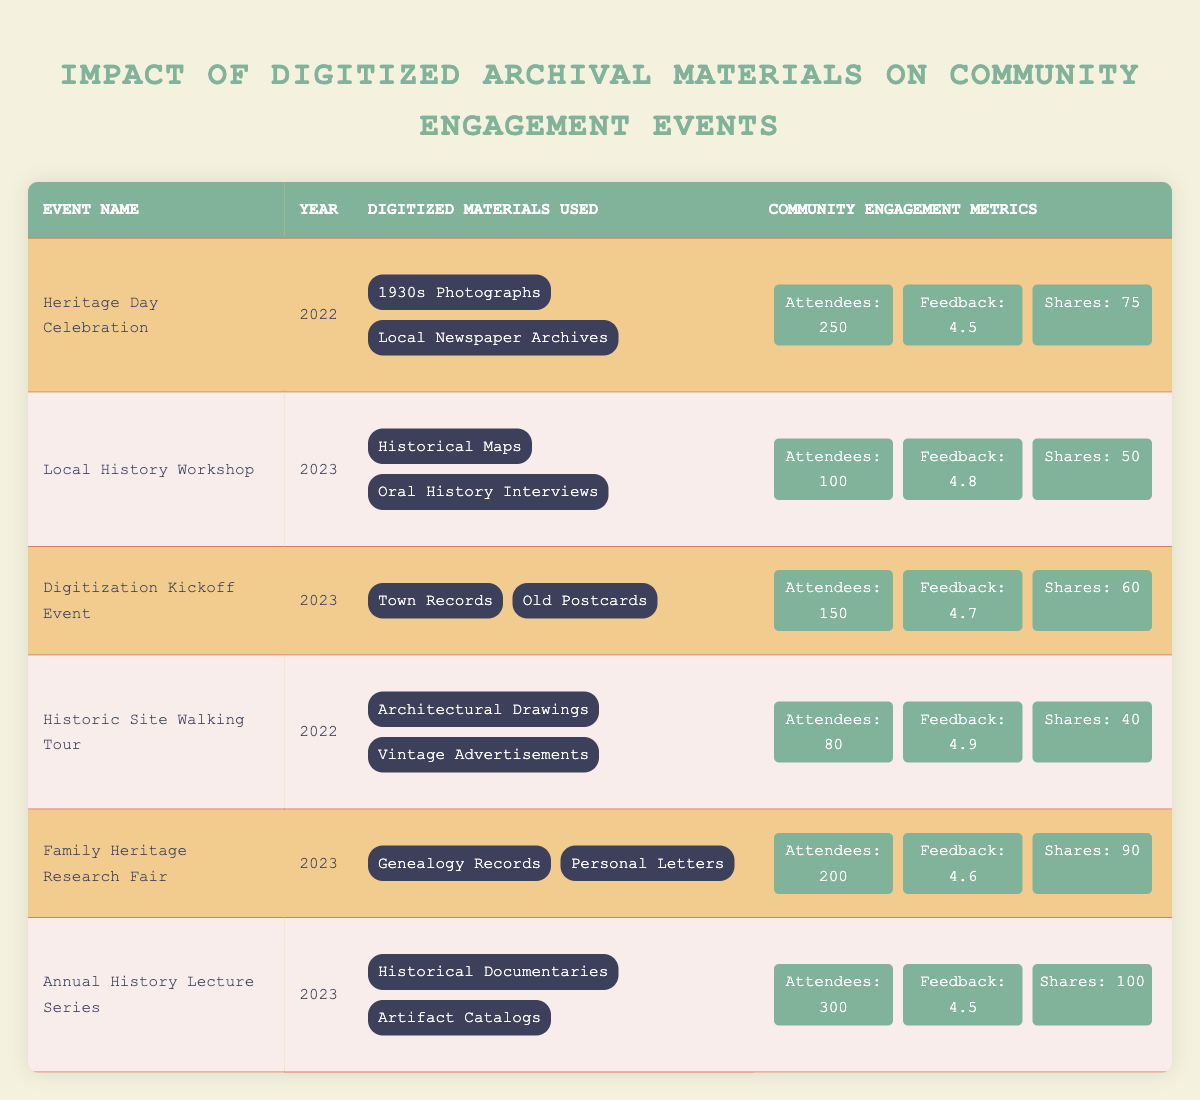What was the community feedback score for the Family Heritage Research Fair? The community feedback score for the Family Heritage Research Fair can be found directly in the fourth column of the corresponding row for that event. The score listed is 4.6.
Answer: 4.6 Which event in 2023 had the highest number of attendees? The events in 2023 are the Local History Workshop, Digitization Kickoff Event, Family Heritage Research Fair, and Annual History Lecture Series. Comparing their attendees: 100, 150, 200, and 300 respectively, the Annual History Lecture Series has the highest number of attendees at 300.
Answer: Annual History Lecture Series How many social media shares were recorded for the Heritage Day Celebration? Looking at the row for the Heritage Day Celebration in the fourth column, the social media shares recorded are 75.
Answer: 75 What is the average community feedback score across all events listed in the table? To find the average community feedback score, sum the individual scores: (4.5 + 4.8 + 4.7 + 4.9 + 4.6 + 4.5) = 29 and divide by the number of events, which is 6. So, 29/6 = 4.83.
Answer: 4.83 Did the Historic Site Walking Tour have more attendees than the Local History Workshop? The number of attendees for the Historic Site Walking Tour is 80, while for the Local History Workshop it is 100. Since 80 is less than 100, the statement is false.
Answer: No What are the digitized materials used in the Digitization Kickoff Event? In the row for the Digitization Kickoff Event, the digitized materials used are listed as Town Records and Old Postcards, which can be viewed in the third column.
Answer: Town Records, Old Postcards Which event had exactly 150 attendees, and what was the community feedback score for it? The event with exactly 150 attendees is the Digitization Kickoff Event. The community feedback score for this event, as seen in the relevant row, is 4.7.
Answer: Digitization Kickoff Event; 4.7 What is the total number of social media shares for events held in 2023? The events in 2023 with their respective shares are the Local History Workshop (50), Digitization Kickoff Event (60), Family Heritage Research Fair (90), and Annual History Lecture Series (100). Adding these together gives: 50 + 60 + 90 + 100 = 300.
Answer: 300 Which digitized material was used in the Historic Site Walking Tour that was not used in any other event? The digitized materials used in the Historic Site Walking Tour include Architectural Drawings and Vintage Advertisements. Checking other events, Architectural Drawings is unique to this event as it is not repeated in others.
Answer: Architectural Drawings 